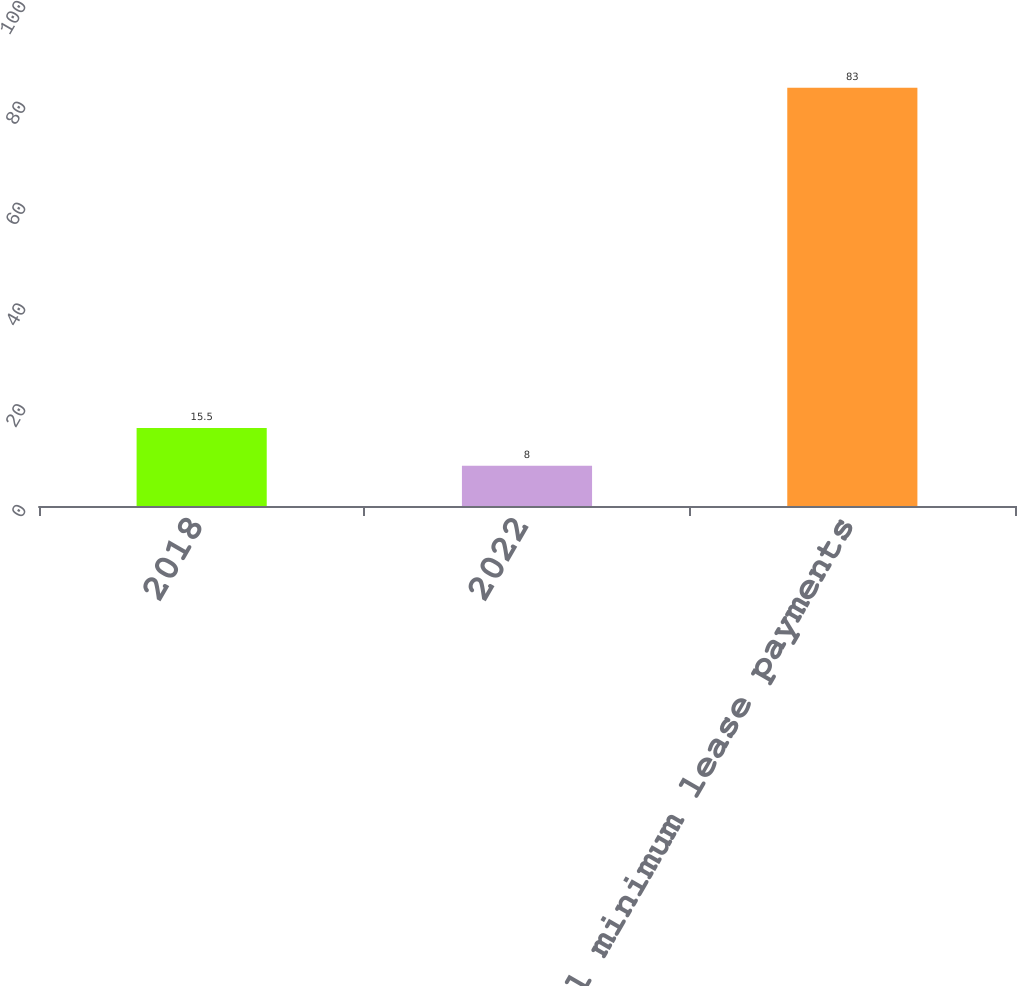Convert chart. <chart><loc_0><loc_0><loc_500><loc_500><bar_chart><fcel>2018<fcel>2022<fcel>Total minimum lease payments<nl><fcel>15.5<fcel>8<fcel>83<nl></chart> 